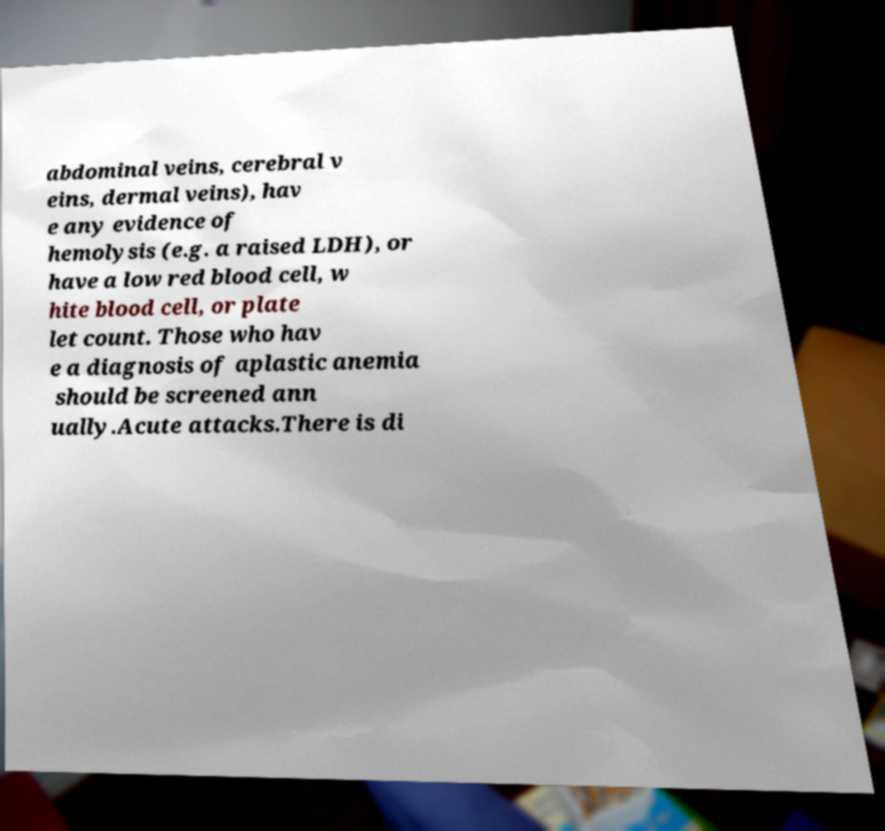For documentation purposes, I need the text within this image transcribed. Could you provide that? abdominal veins, cerebral v eins, dermal veins), hav e any evidence of hemolysis (e.g. a raised LDH), or have a low red blood cell, w hite blood cell, or plate let count. Those who hav e a diagnosis of aplastic anemia should be screened ann ually.Acute attacks.There is di 